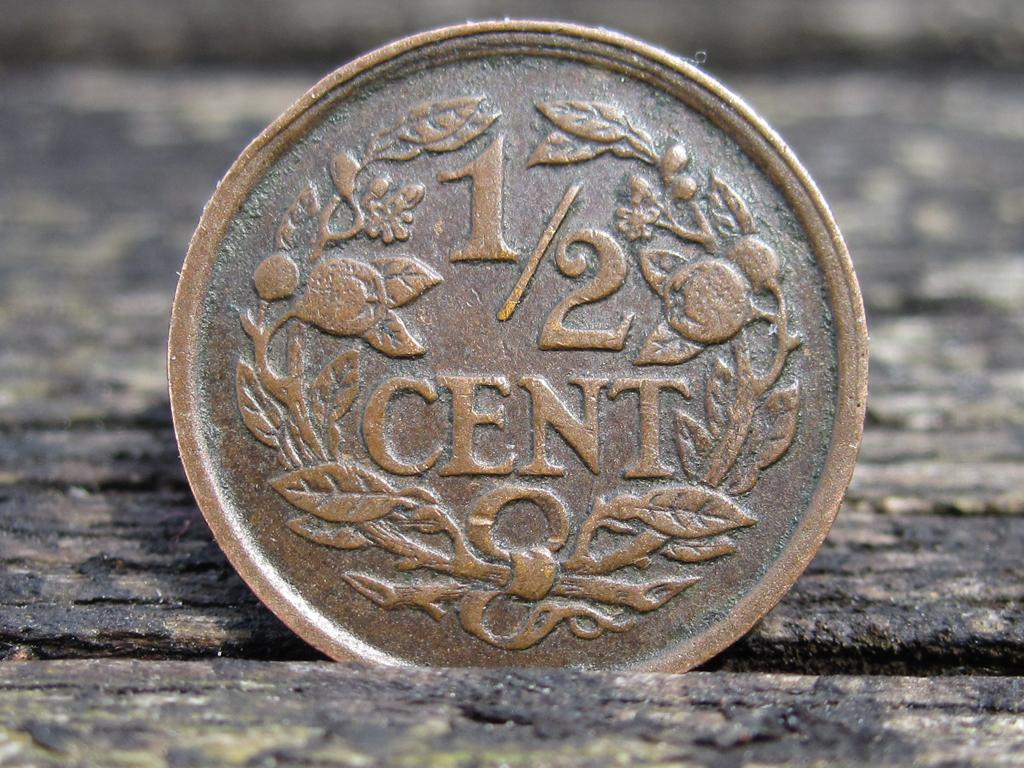What object is visible in the image? There is a coin in the image. On what surface is the coin placed? The coin is on a wooden surface. Are the hands of the person holding the coin visible in the image? There is no person or hands visible in the image; it only shows a coin on a wooden surface. 